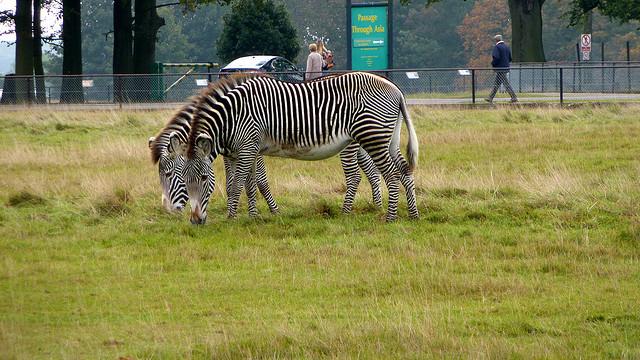Is this the zoo?
Write a very short answer. Yes. Is this a two headed zebra?
Answer briefly. No. Does the zebra live in a zoo?
Keep it brief. Yes. Is the photographers name shown?
Answer briefly. No. What is the number of zebras?
Concise answer only. 2. 